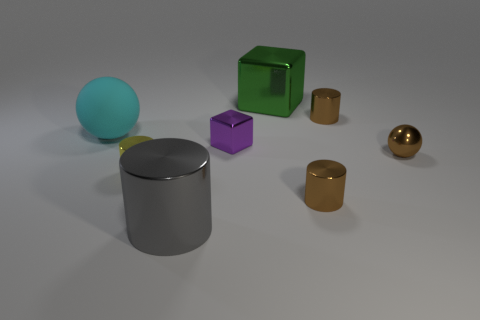Subtract all green blocks. Subtract all yellow balls. How many blocks are left? 1 Add 1 big purple metal cylinders. How many objects exist? 9 Subtract all spheres. How many objects are left? 6 Subtract all big gray spheres. Subtract all big rubber things. How many objects are left? 7 Add 8 metallic balls. How many metallic balls are left? 9 Add 5 red metal cylinders. How many red metal cylinders exist? 5 Subtract 0 cyan blocks. How many objects are left? 8 